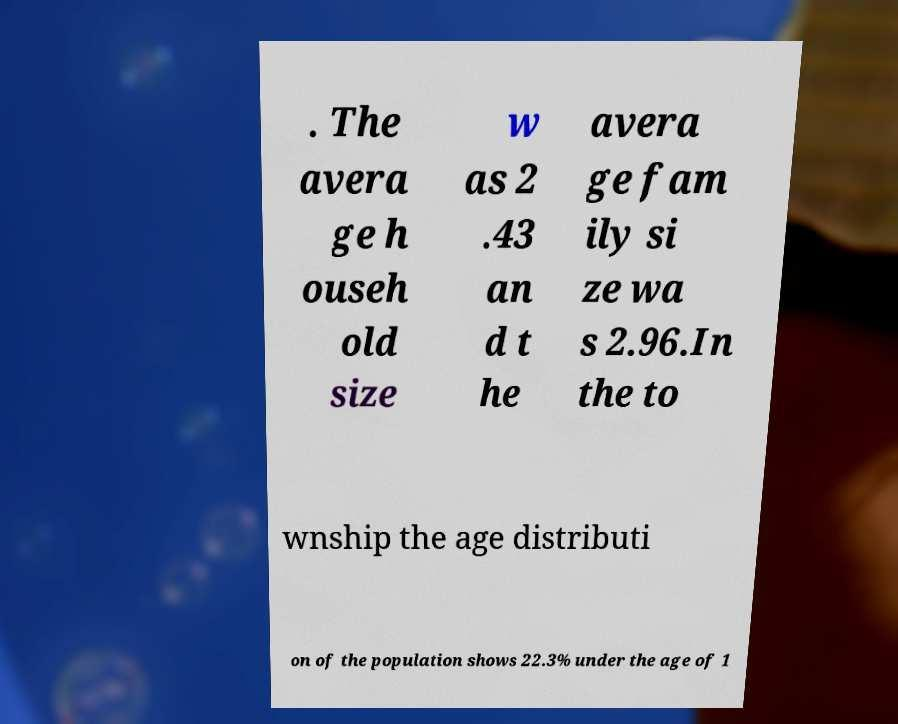Can you accurately transcribe the text from the provided image for me? . The avera ge h ouseh old size w as 2 .43 an d t he avera ge fam ily si ze wa s 2.96.In the to wnship the age distributi on of the population shows 22.3% under the age of 1 